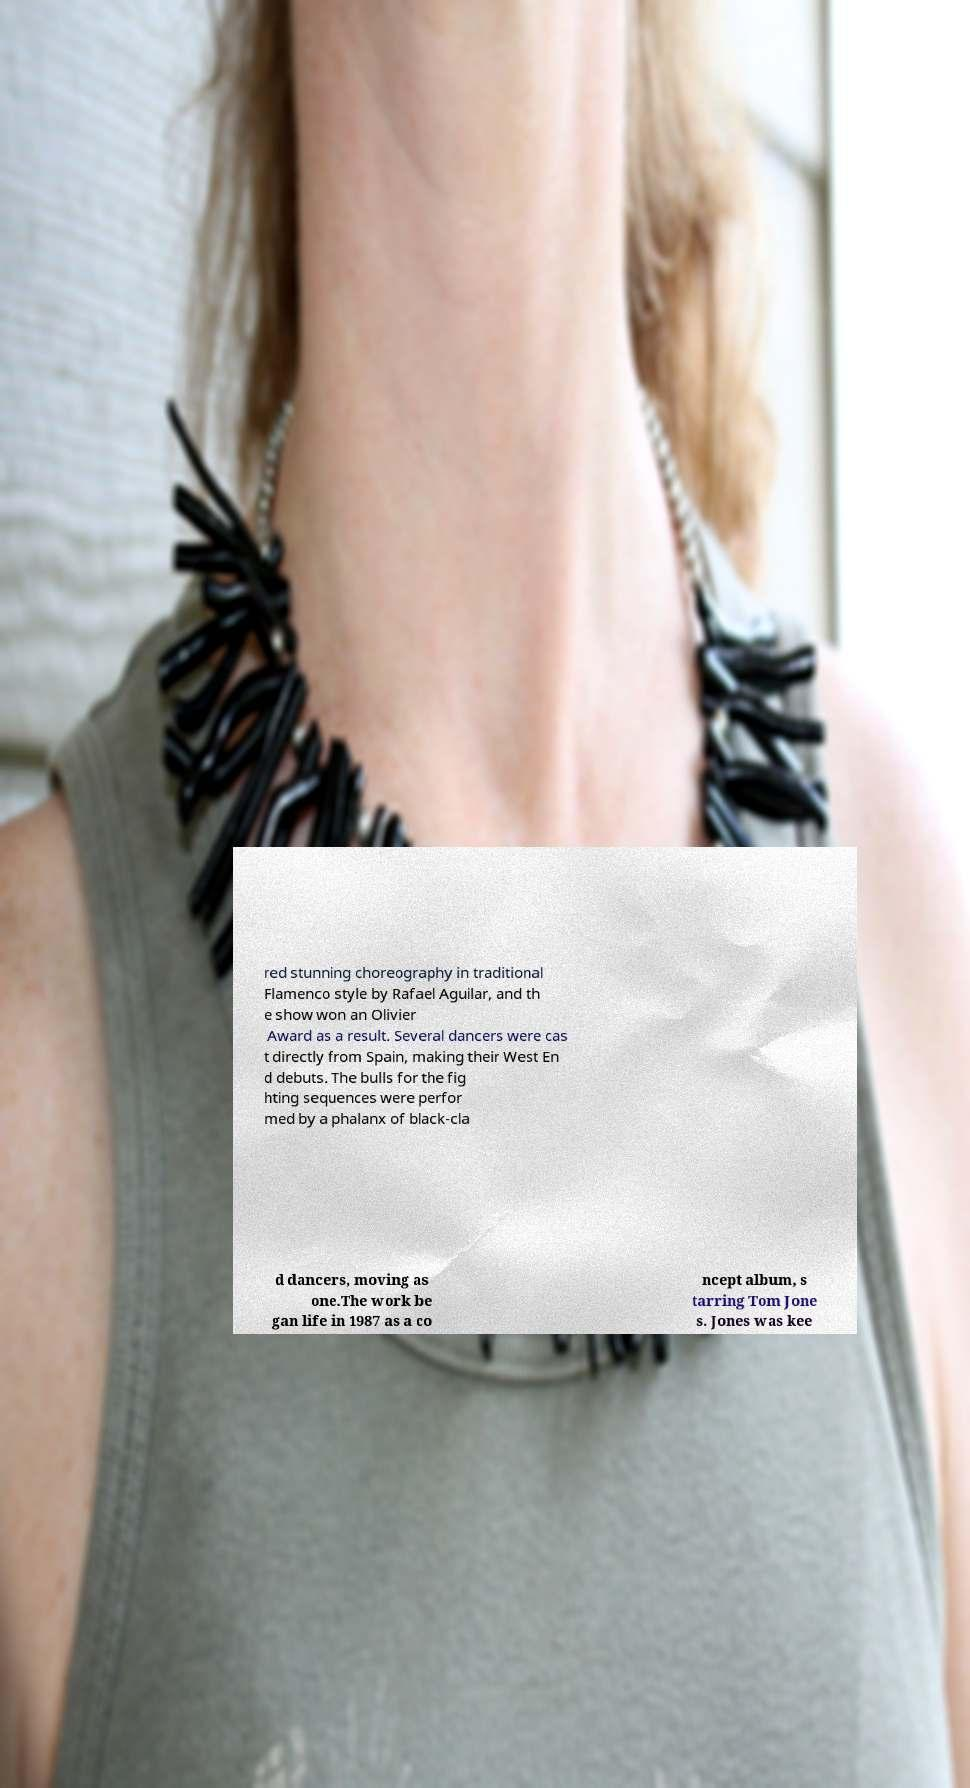Please read and relay the text visible in this image. What does it say? red stunning choreography in traditional Flamenco style by Rafael Aguilar, and th e show won an Olivier Award as a result. Several dancers were cas t directly from Spain, making their West En d debuts. The bulls for the fig hting sequences were perfor med by a phalanx of black-cla d dancers, moving as one.The work be gan life in 1987 as a co ncept album, s tarring Tom Jone s. Jones was kee 